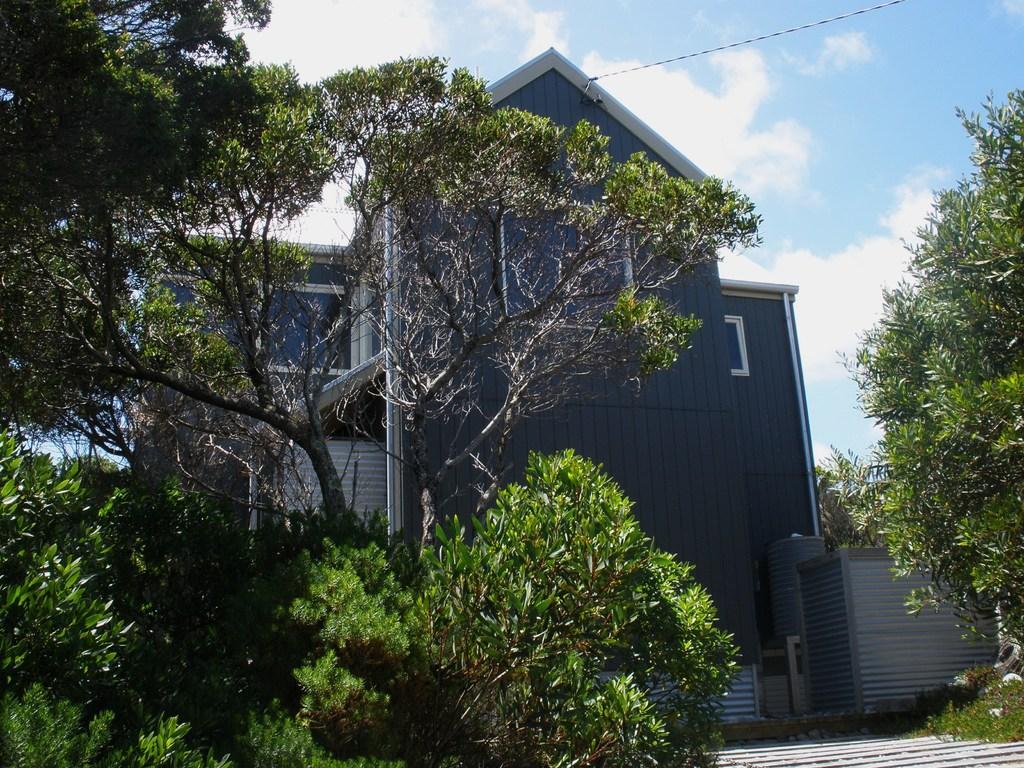Please provide a concise description of this image. In this image we can see trees. Also there is a building. In the background there is sky with clouds. At the top there is a wire. 